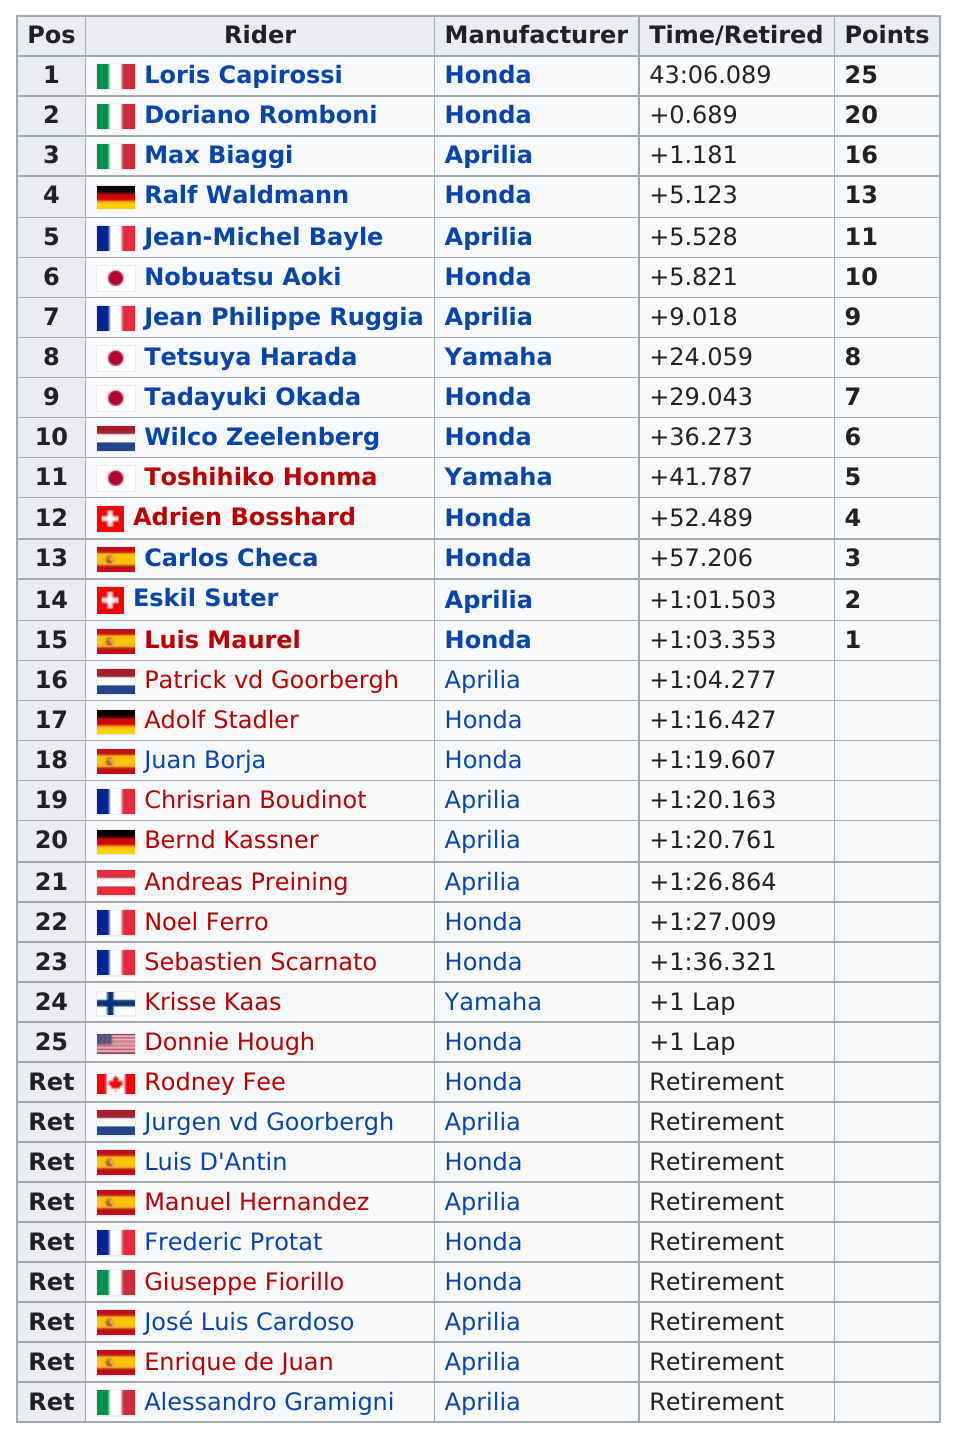Highlight a few significant elements in this photo. Loris Capirossi has the most points. Honda is the manufacturer of Loris Capirossi and Ralf Waldmann. There are 34 riders listed. It is unclear if Max Biaggi or Ralf Waldmann have more points. In the competition, Luis Maurel scored the least amount of points among all riders. 